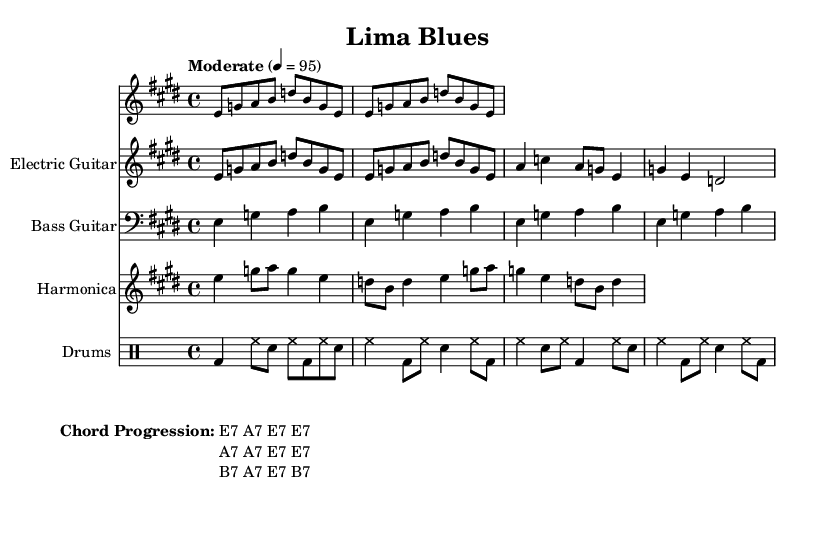What is the key signature of this music? The key signature is E major, which has four sharps (F#, C#, G#, D#). This can be identified by looking to the beginning of the score, where key signatures are indicated.
Answer: E major What is the time signature of this music? The time signature is 4/4, which means there are four beats in each measure and the quarter note gets one beat. This number is prominently displayed at the beginning of the piece, right after the key signature.
Answer: 4/4 What is the tempo marking of this piece? The tempo marking is "Moderate" with a metronome marking of 4 = 95. This is shown at the beginning of the score, indicating how fast the piece should be played.
Answer: Moderate How many measures are there in the electric guitar part? There are nine measures in the electric guitar part. By counting the measures in the staff where the electric guitar is indicated, one can determine this total.
Answer: 9 What is the chord progression used in this piece? The chord progression is E7 A7 E7 E7, A7 A7 E7 E7, B7 A7 E7 B7. This can be found in the markup section towards the end of the score, outlining the chords for the accompanying instruments.
Answer: E7 A7 E7 E7 A7 A7 E7 E7 B7 A7 E7 B7 What instruments are featured in this composition? The instruments featured are electric guitar, bass guitar, harmonica, and drums. Each instrument is accompanied by its own staff, making it clear which parts are being played by whom.
Answer: Electric guitar, bass guitar, harmonica, drums What genre does this music exemplify? This music exemplifies Electric Blues, a genre known for its soulful expression and instrumental emphasis on electric guitar, bass, harmonica, and drums, which are all represented in this score.
Answer: Electric Blues 